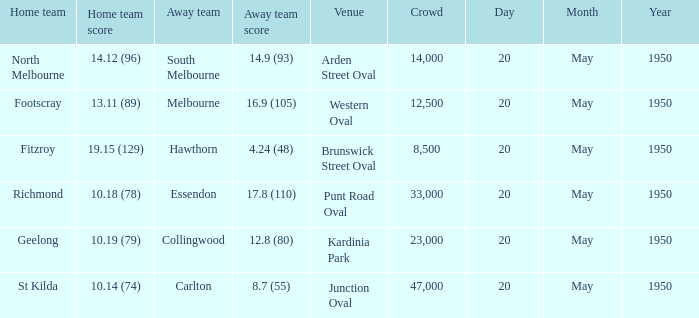At which venue did the away team achieve a score of 1 Arden Street Oval. 